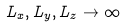Convert formula to latex. <formula><loc_0><loc_0><loc_500><loc_500>L _ { x } , L _ { y } , L _ { z } \rightarrow \infty</formula> 